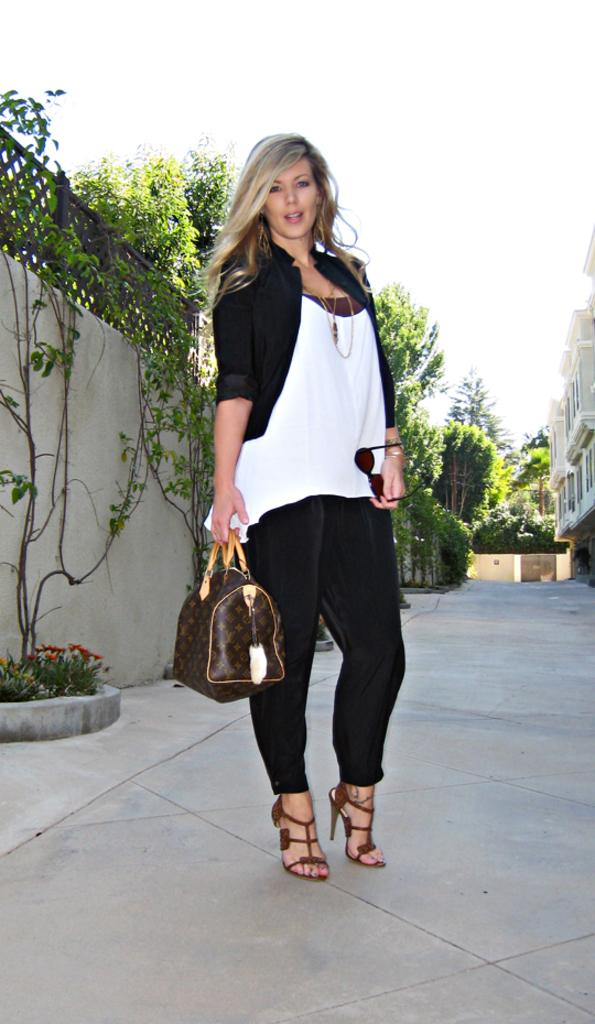What is the woman in the image doing? The woman is standing on a path in the image. What is the woman holding in the image? The woman is holding a handbag. What can be seen in the background of the image? There are plants, a wall, the sky, and trees visible in the background of the image. What type of pie is the woman eating in the image? There is no pie present in the image, and the woman is not eating anything. What time of day is it in the image? The time of day cannot be determined from the image, as there are no specific clues or indicators. 